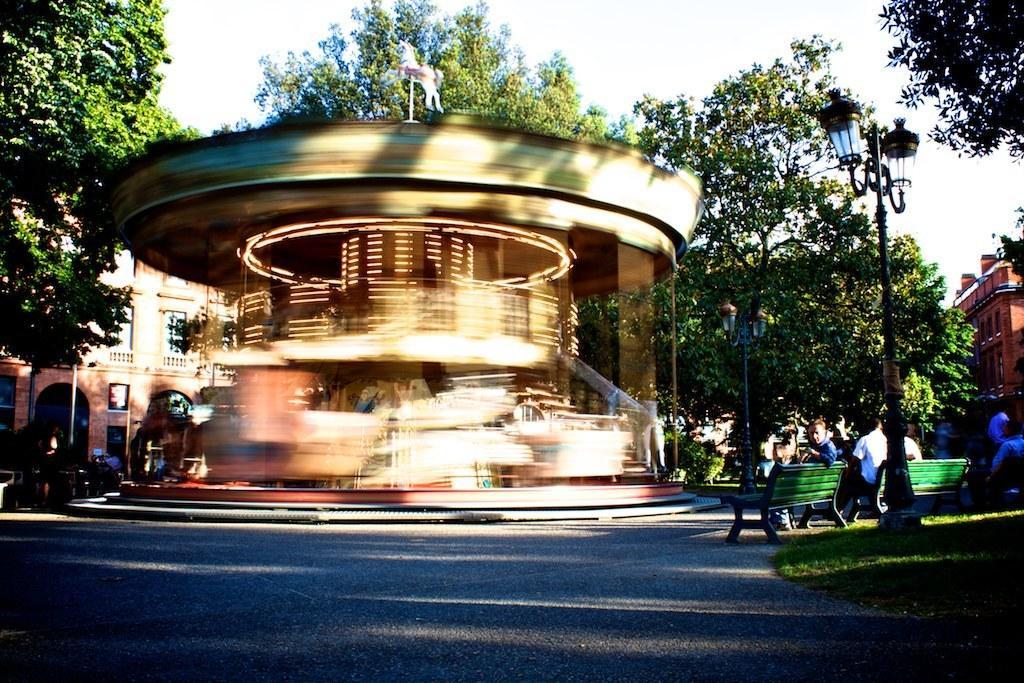In one or two sentences, can you explain what this image depicts? In this image there are a few people seated on the benches, beside the benches there are two lamp posts, in front of the benches there are building and trees, in front of the building there is road surface. 